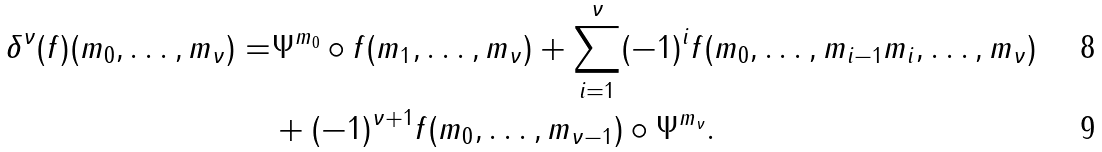<formula> <loc_0><loc_0><loc_500><loc_500>\delta ^ { \nu } ( f ) ( m _ { 0 } , \dots , m _ { \nu } ) = & \Psi ^ { m _ { 0 } } \circ f ( m _ { 1 } , \dots , m _ { \nu } ) + \sum _ { i = 1 } ^ { \nu } ( - 1 ) ^ { i } f ( m _ { 0 } , \dots , m _ { i - 1 } m _ { i } , \dots , m _ { \nu } ) \\ & + ( - 1 ) ^ { \nu + 1 } f ( m _ { 0 } , \dots , m _ { \nu - 1 } ) \circ \Psi ^ { m _ { \nu } } .</formula> 